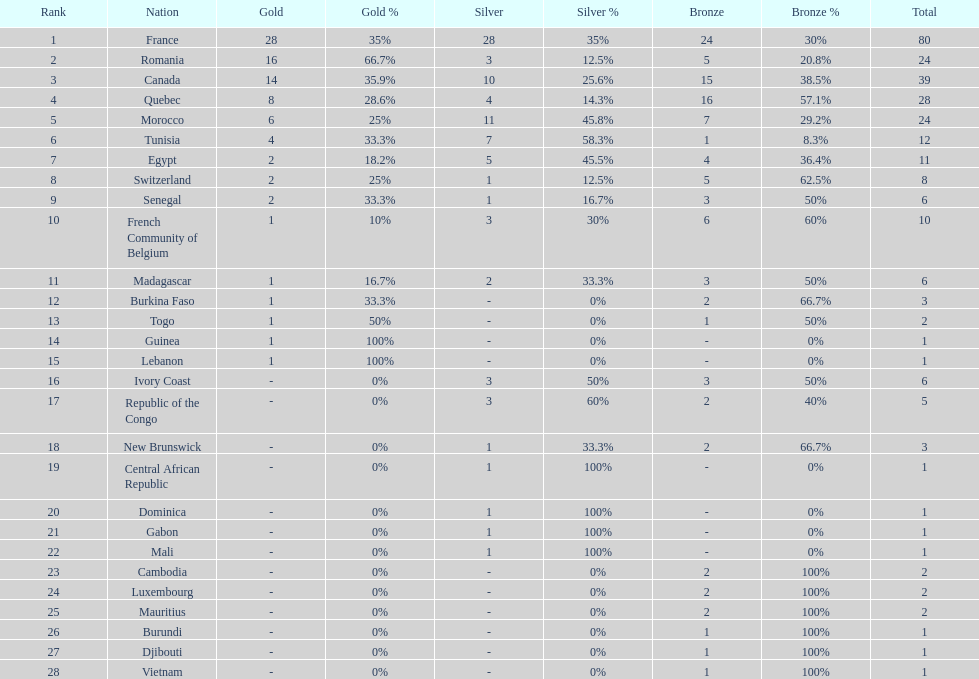What was the total medal count of switzerland? 8. 